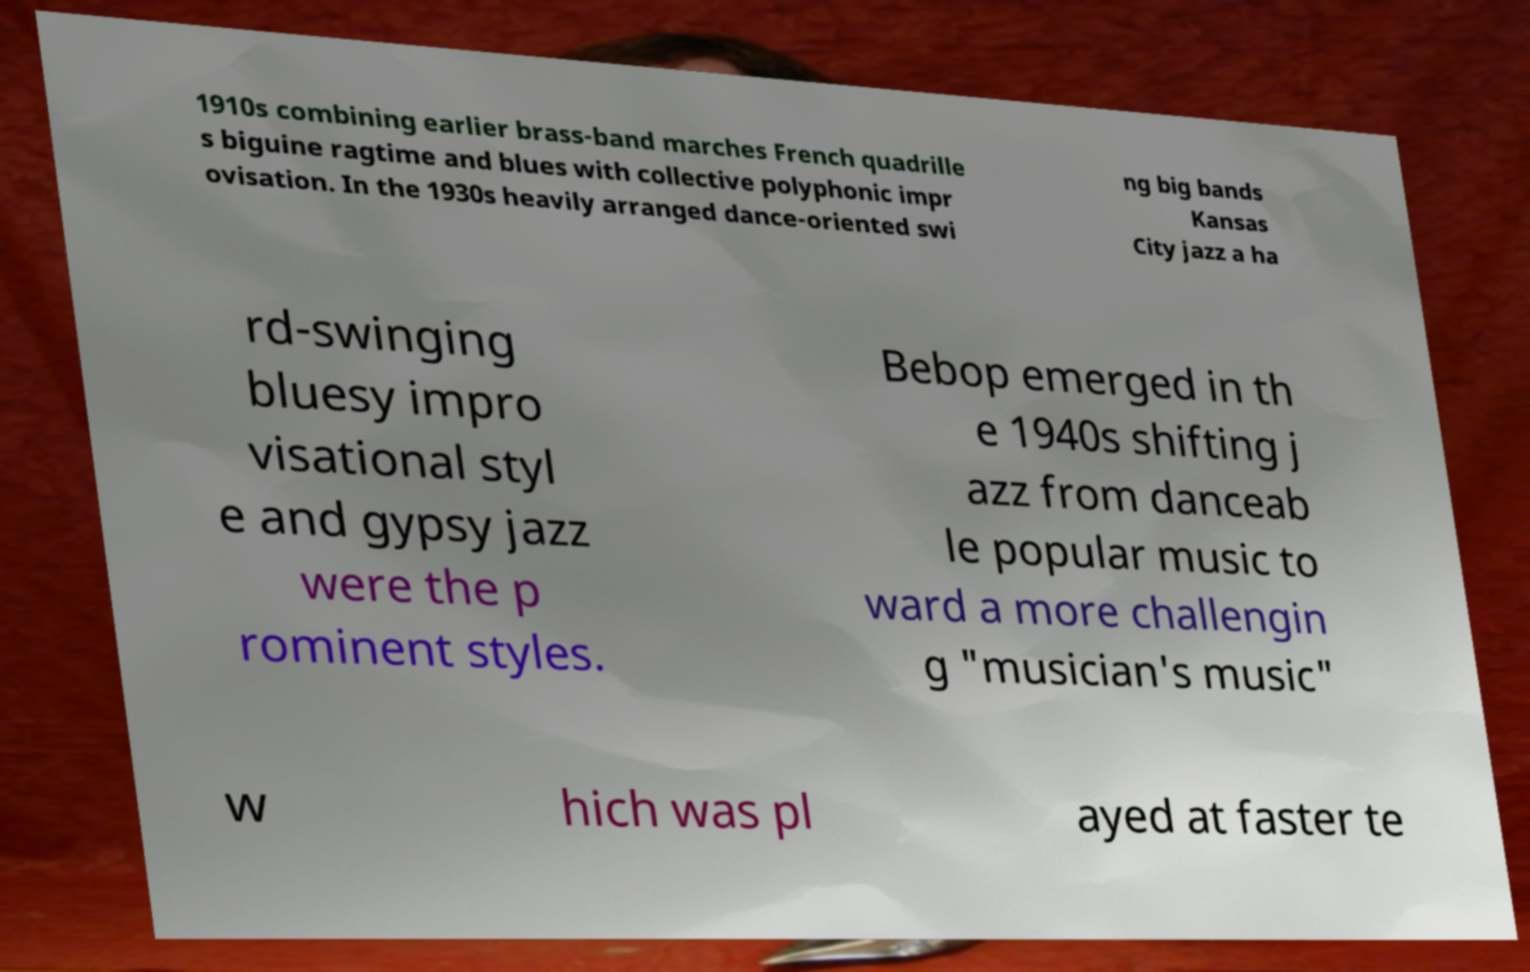Could you assist in decoding the text presented in this image and type it out clearly? 1910s combining earlier brass-band marches French quadrille s biguine ragtime and blues with collective polyphonic impr ovisation. In the 1930s heavily arranged dance-oriented swi ng big bands Kansas City jazz a ha rd-swinging bluesy impro visational styl e and gypsy jazz were the p rominent styles. Bebop emerged in th e 1940s shifting j azz from danceab le popular music to ward a more challengin g "musician's music" w hich was pl ayed at faster te 